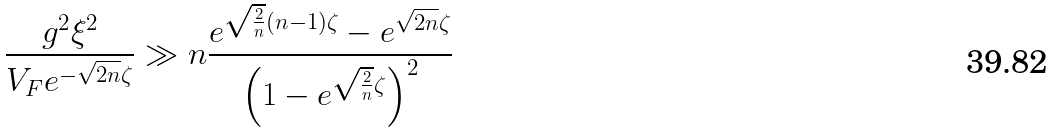<formula> <loc_0><loc_0><loc_500><loc_500>\frac { g ^ { 2 } \xi ^ { 2 } } { V _ { F } e ^ { - \sqrt { 2 n } \zeta } } \gg n \frac { e ^ { \sqrt { \frac { 2 } { n } } ( n - 1 ) \zeta } - e ^ { \sqrt { 2 n } \zeta } } { \left ( 1 - e ^ { \sqrt { \frac { 2 } { n } } \zeta } \right ) ^ { 2 } }</formula> 